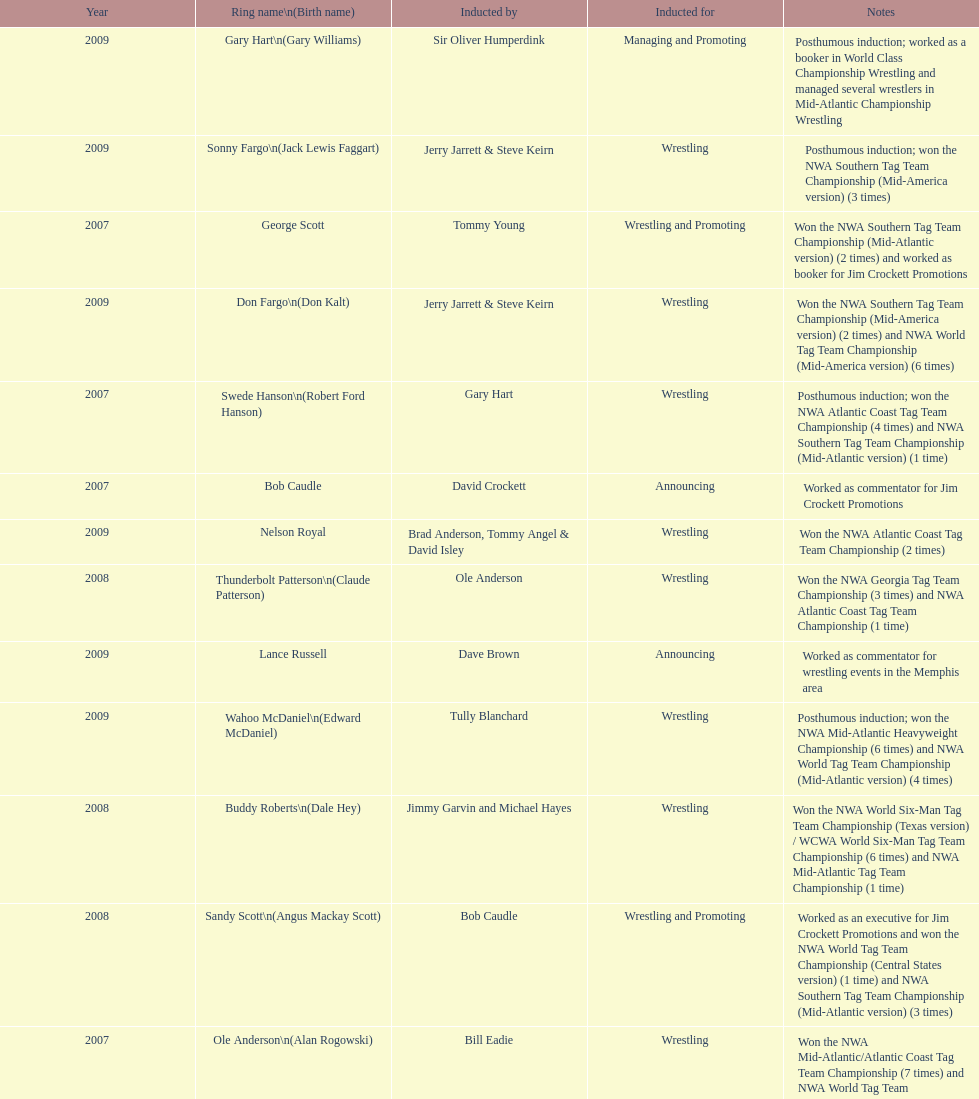Who's real name is dale hey, grizzly smith or buddy roberts? Buddy Roberts. 